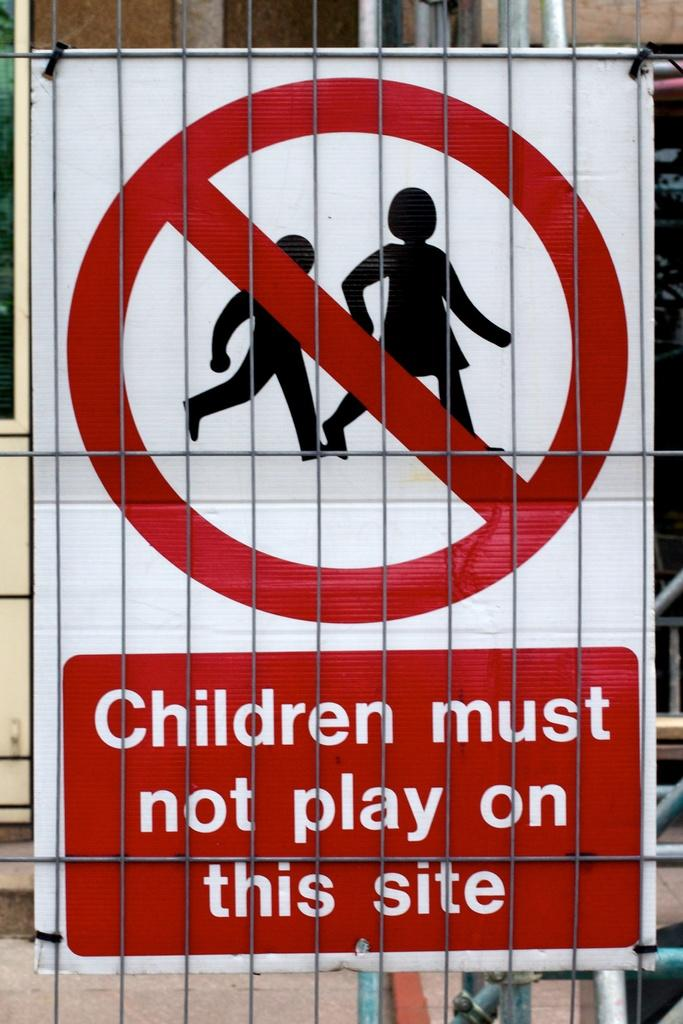Provide a one-sentence caption for the provided image. A signs states that, "Children must not play on this site.". 